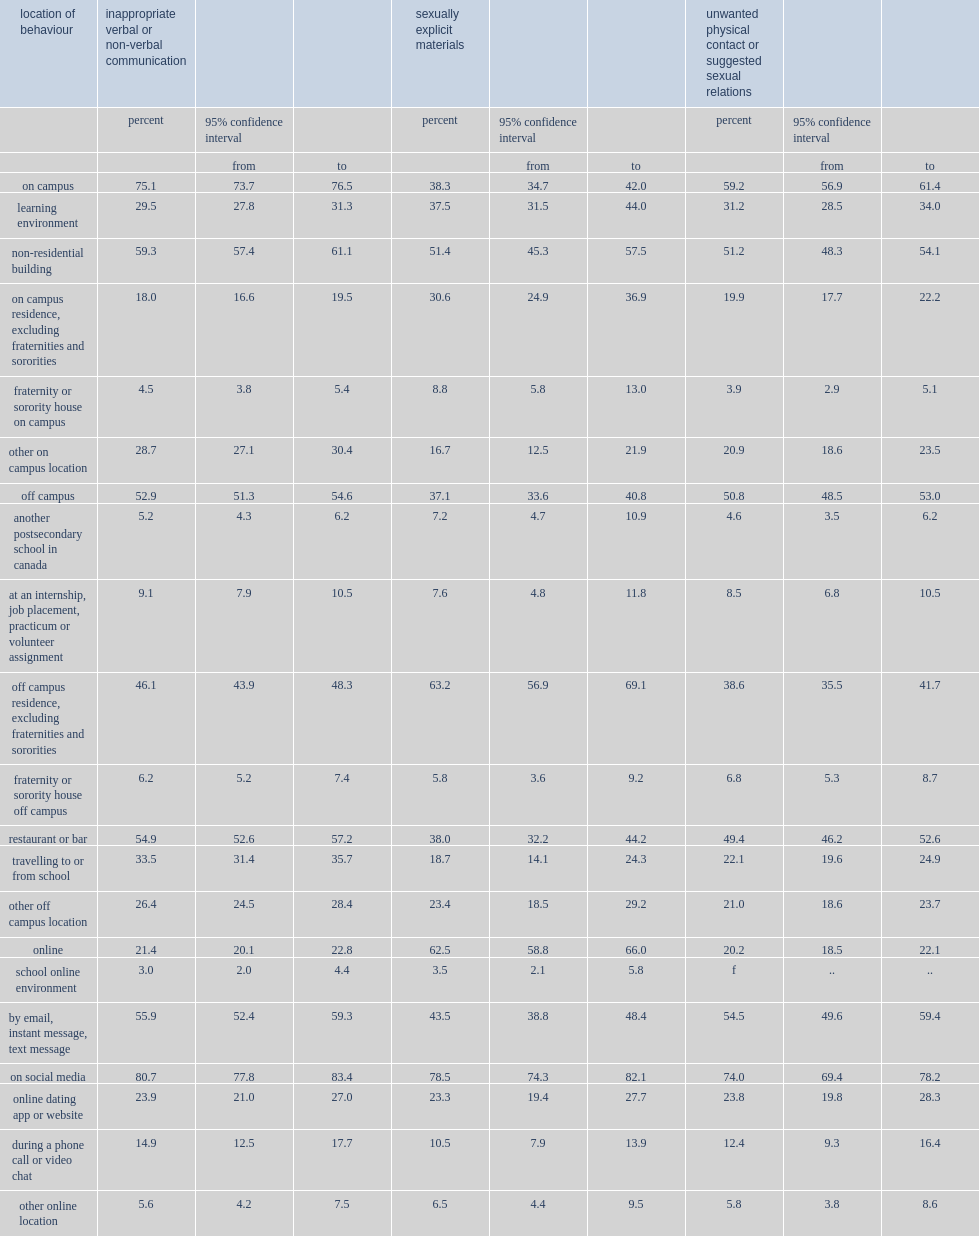Given their association with digital videos and images, behaviours related to sexually explicit materials, how many percent of most often occurred in a school-related online environment? 62.5. How many percent of social media which was the most common online environment in which students experienced sexually explicit material? 78.5. How many percent of students who experienced inappropriate communication on campus said that at least one incident had happened at a non-residential building (such as a library, cafeteria or gym)? 59.3. What was the percent of restaurants and bars were frequently the setting of behaviours related to inappropriate communication that happened off campus? 54.9. What was the percent of restaurants and bars were frequently the setting of behaviours related to physical contact or suggested sexual relations that happened off campus? 49.4. 